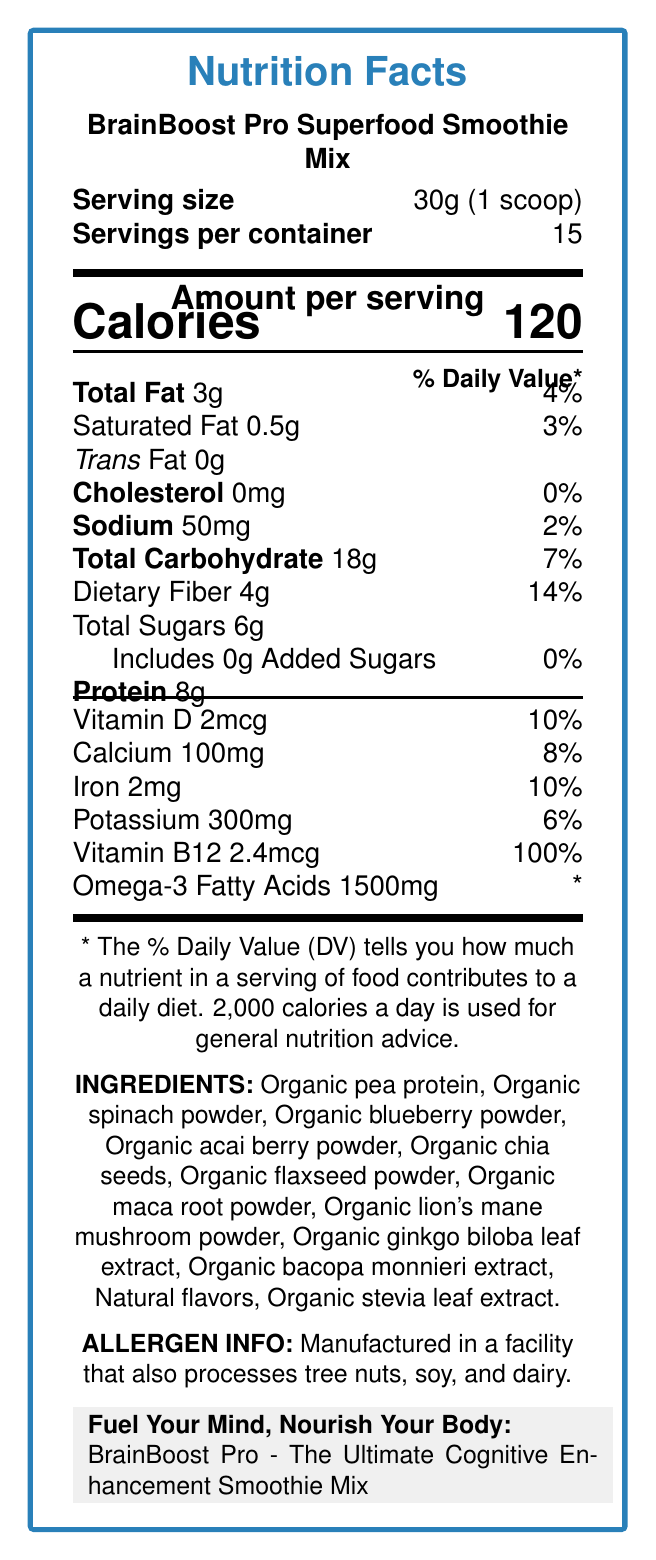what is the serving size? The serving size is clearly listed as "30g (1 scoop)" on the document.
Answer: 30g (1 scoop) how many calories are in one serving? The document states there are 120 calories per serving.
Answer: 120 what is the total fat content per serving? The total fat per serving is listed as 3g in the document.
Answer: 3g how much sodium does one serving contain? The sodium content per serving is 50mg according to the document.
Answer: 50mg what is the protein content per serving? The protein content per serving is indicated to be 8g in the document.
Answer: 8g which vitamin is present at 100% of the daily value per serving? A. Vitamin D B. Calcium C. Iron D. Vitamin B12 The document lists Vitamin B12 at 100% of the daily value per serving.
Answer: D how many milligrams of omega-3 fatty acids are in one serving? The document mentions 1500mg of omega-3 fatty acids per serving.
Answer: 1500mg are there any added sugars in this product? The document specifies that there are 0g of added sugars in this product.
Answer: No does the product contain any cholesterol? The document shows that there is 0mg of cholesterol per serving.
Answer: No how many servings are in one container? The document states that there are 15 servings per container.
Answer: 15 is the product suitable for someone with a tree nut allergy? The product is manufactured in a facility that also processes tree nuts, as indicated in the allergen information.
Answer: No which ingredients in the product support cognitive function? The document claims that Lion's mane mushroom and Ginkgo biloba support cognitive function.
Answer: Lion's mane mushroom and Ginkgo biloba which ingredient contributes to the product's flavor without adding sugars? The document lists "Organic stevia leaf extract" as an ingredient, which adds flavor without sugar.
Answer: Organic stevia leaf extract how should you prepare the smoothie mix? A. Mix with water B. Mix with plant-based milk C. Add to a smoothie recipe D. All of the above The instructions suggest mixing with water, plant-based milk, or adding to a smoothie recipe for preparation.
Answer: D what is the daily value percentage of dietary fiber per serving? The document states that the dietary fiber per serving is 14% of the daily value.
Answer: 14% which statement about the product is true? A. Contains added sugars B. High in sodium C. Excellent source of omega-3 fatty acids D. Low in protein The document highlights that the product is an excellent source of omega-3 fatty acids.
Answer: C summarize the entire document in one sentence. The document summarizes the nutritional content, serving size, ingredients, allergen information, and preparation instructions, emphasizing the product's cognitive benefits and marketing claims.
Answer: The document provides nutrition facts, ingredients, allergen info, and preparation instructions for BrainBoost Pro Superfood Smoothie Mix, highlighting its brain-boosting benefits and cognitive support properties. what is the total carbohydrate content per serving? The document lists the total carbohydrate content as 18g per serving.
Answer: 18g how does the product support cognitive function? The document specifically mentions that Lion's mane mushroom and Ginkgo biloba support cognitive function.
Answer: It contains Lion's mane mushroom and Ginkgo biloba, which are known for their cognitive benefits. what is the target audience for this product? The marketing tagline mentions that the target audience includes health-conscious professionals, students, and individuals looking to enhance mental performance.
Answer: Health-conscious professionals, students, and individuals seeking to optimize mental performance when was the product first released to the market? The document does not provide any information regarding the release date of the product.
Answer: Cannot be determined 